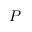Convert formula to latex. <formula><loc_0><loc_0><loc_500><loc_500>P</formula> 